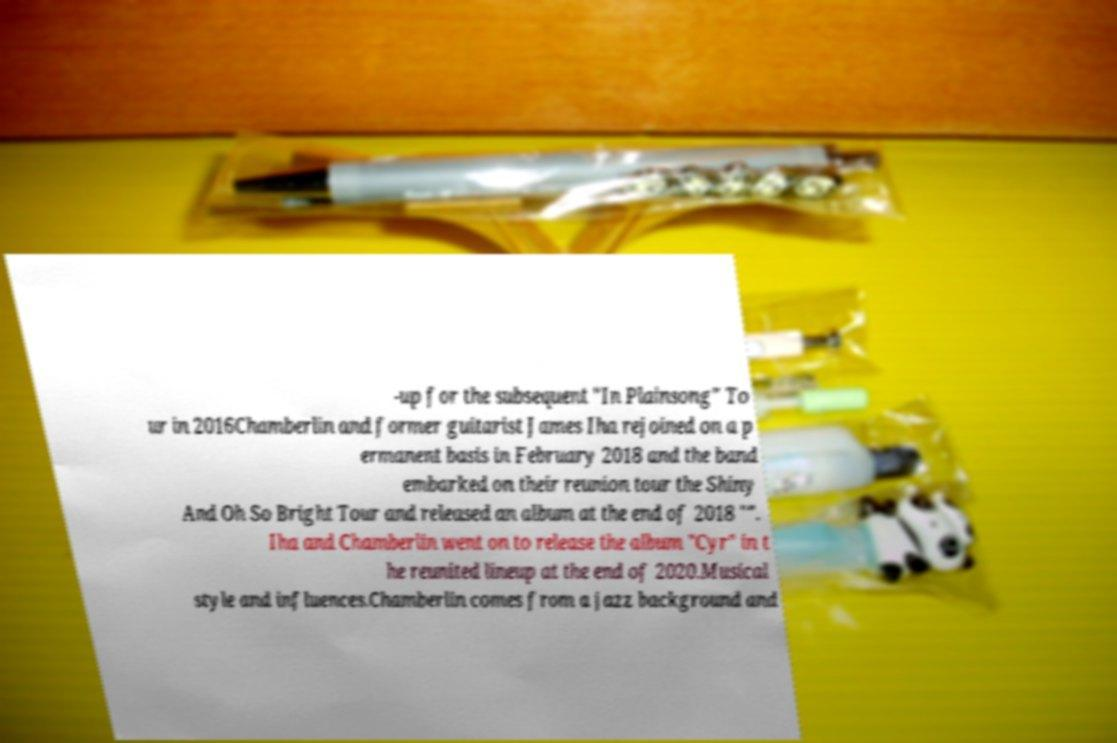Could you extract and type out the text from this image? -up for the subsequent "In Plainsong" To ur in 2016Chamberlin and former guitarist James Iha rejoined on a p ermanent basis in February 2018 and the band embarked on their reunion tour the Shiny And Oh So Bright Tour and released an album at the end of 2018 "". Iha and Chamberlin went on to release the album "Cyr" in t he reunited lineup at the end of 2020.Musical style and influences.Chamberlin comes from a jazz background and 